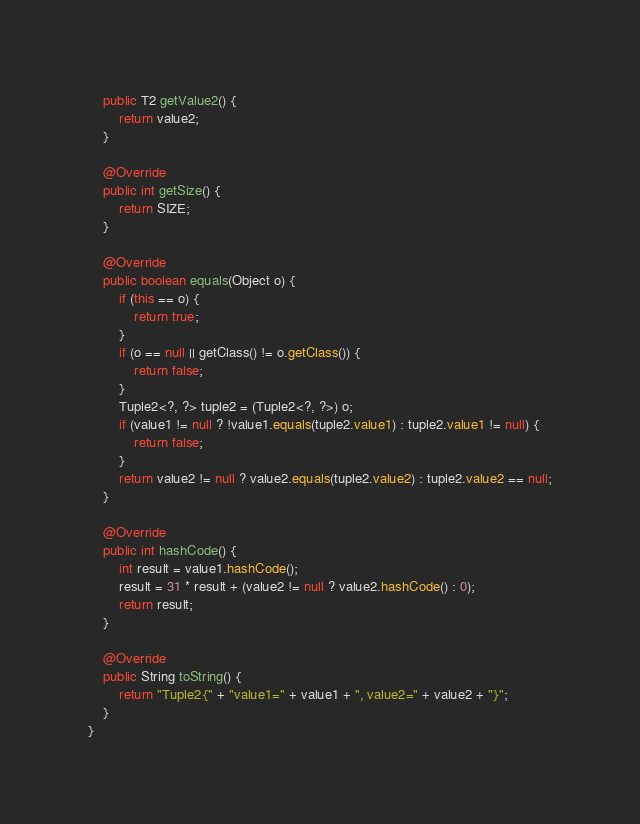Convert code to text. <code><loc_0><loc_0><loc_500><loc_500><_Java_>
    public T2 getValue2() {
        return value2;
    }

    @Override
    public int getSize() {
        return SIZE;
    }

    @Override
    public boolean equals(Object o) {
        if (this == o) {
            return true;
        }
        if (o == null || getClass() != o.getClass()) {
            return false;
        }
        Tuple2<?, ?> tuple2 = (Tuple2<?, ?>) o;
        if (value1 != null ? !value1.equals(tuple2.value1) : tuple2.value1 != null) {
            return false;
        }
        return value2 != null ? value2.equals(tuple2.value2) : tuple2.value2 == null;
    }

    @Override
    public int hashCode() {
        int result = value1.hashCode();
        result = 31 * result + (value2 != null ? value2.hashCode() : 0);
        return result;
    }

    @Override
    public String toString() {
        return "Tuple2{" + "value1=" + value1 + ", value2=" + value2 + "}";
    }
}
</code> 